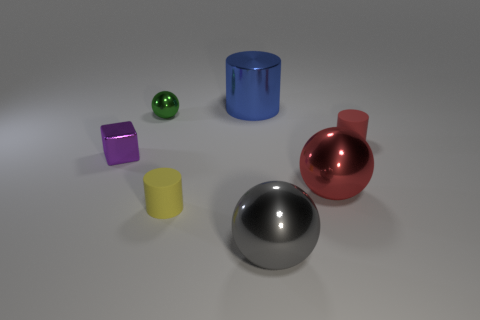There is a green object; is its shape the same as the red object that is behind the small cube?
Your response must be concise. No. How many other things are made of the same material as the tiny ball?
Provide a short and direct response. 4. The matte cylinder behind the tiny metallic object in front of the tiny matte object that is behind the purple thing is what color?
Keep it short and to the point. Red. There is a large thing in front of the tiny matte object that is in front of the red metallic thing; what is its shape?
Provide a short and direct response. Sphere. Are there more tiny things that are in front of the big gray sphere than big gray things?
Your answer should be very brief. No. There is a matte object that is in front of the small purple metallic thing; is its shape the same as the tiny red object?
Provide a short and direct response. Yes. Are there any red metallic things that have the same shape as the green metal object?
Your answer should be very brief. Yes. What number of things are metallic balls in front of the red matte thing or tiny yellow cylinders?
Provide a short and direct response. 3. Are there more metallic blocks than tiny blue rubber things?
Keep it short and to the point. Yes. Is there a blue metal object of the same size as the red rubber cylinder?
Your answer should be compact. No. 